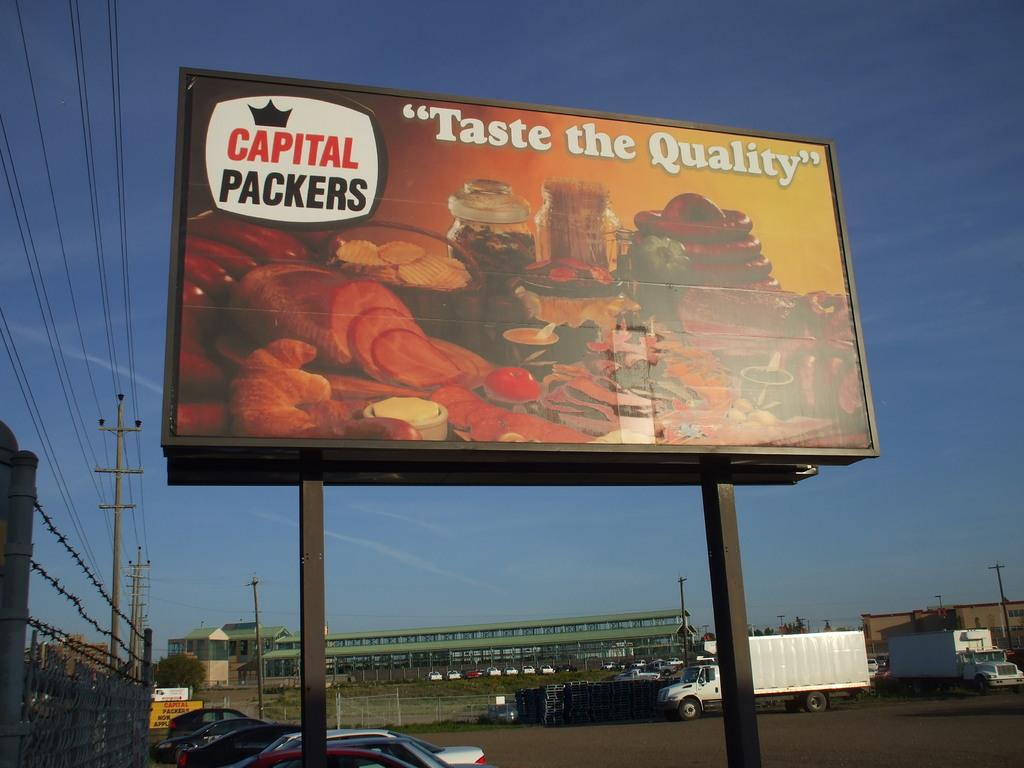<image>
Create a compact narrative representing the image presented. A billboard that says Capital Packers Taste the Quality. 